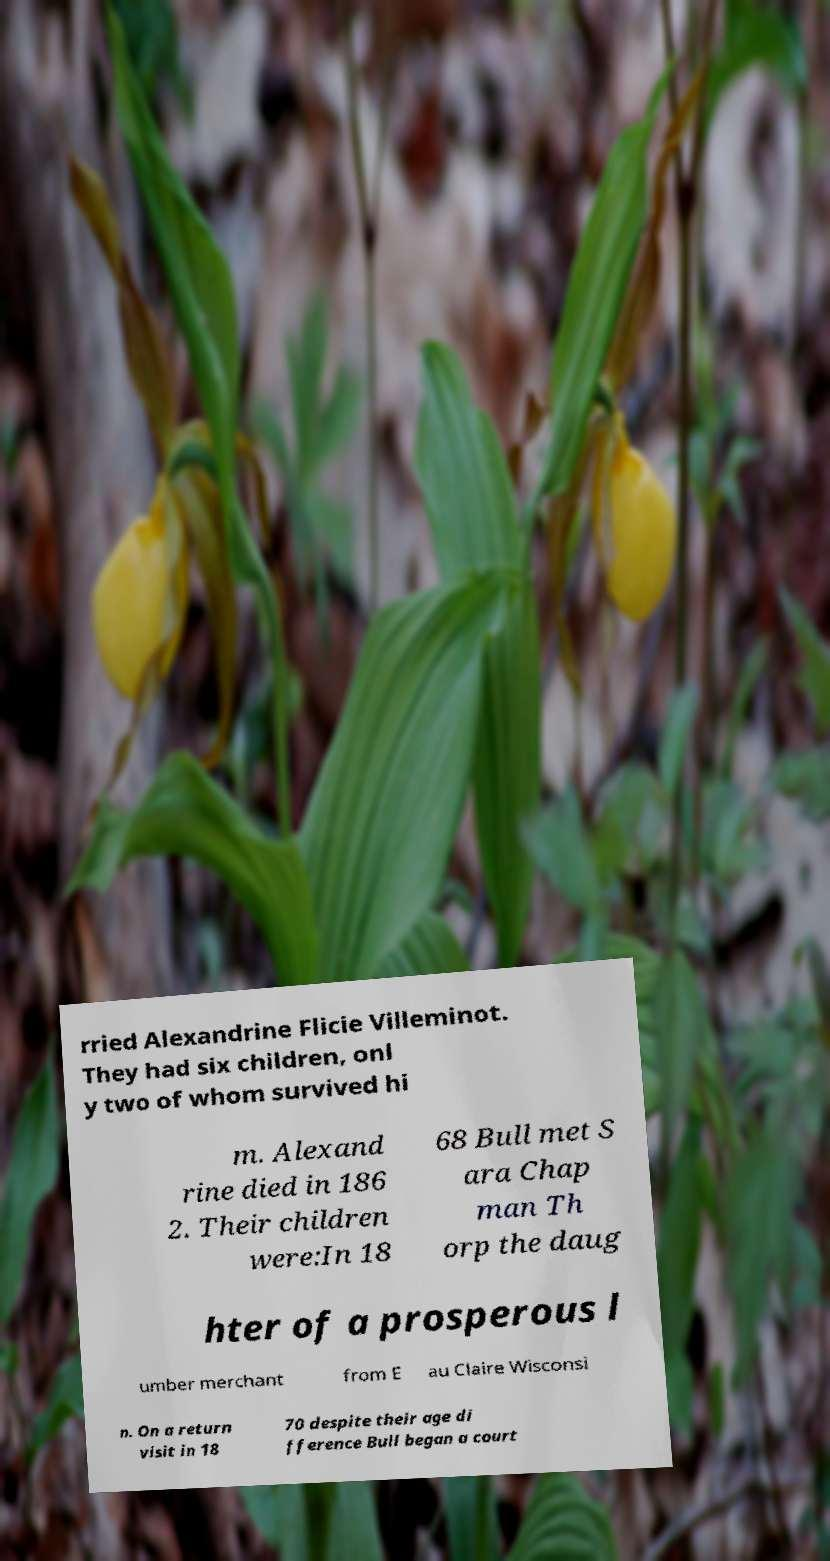Could you extract and type out the text from this image? rried Alexandrine Flicie Villeminot. They had six children, onl y two of whom survived hi m. Alexand rine died in 186 2. Their children were:In 18 68 Bull met S ara Chap man Th orp the daug hter of a prosperous l umber merchant from E au Claire Wisconsi n. On a return visit in 18 70 despite their age di fference Bull began a court 